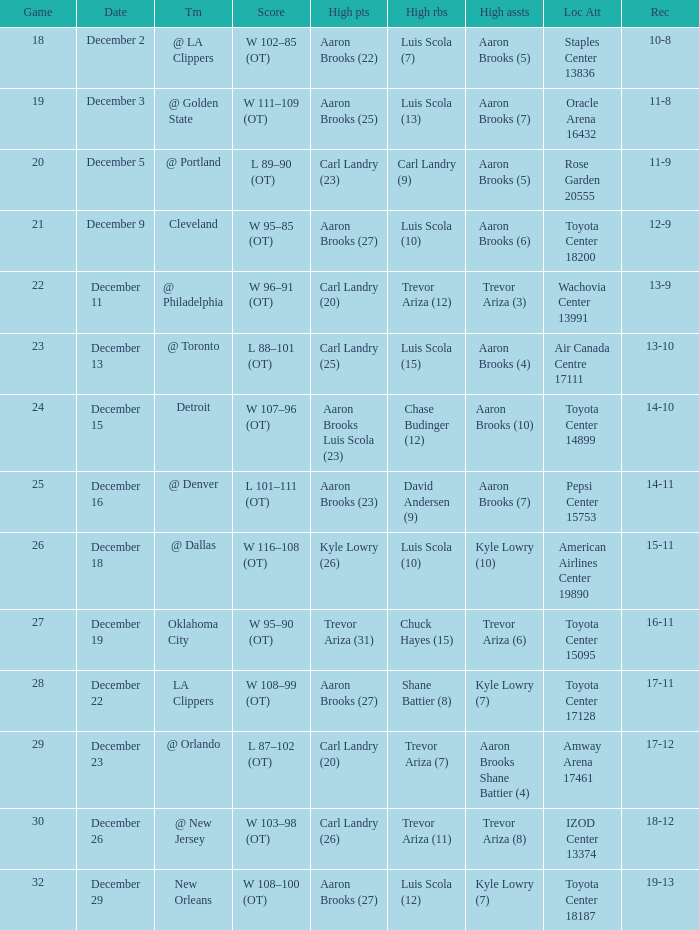What's the end score of the game where Shane Battier (8) did the high rebounds? W 108–99 (OT). 